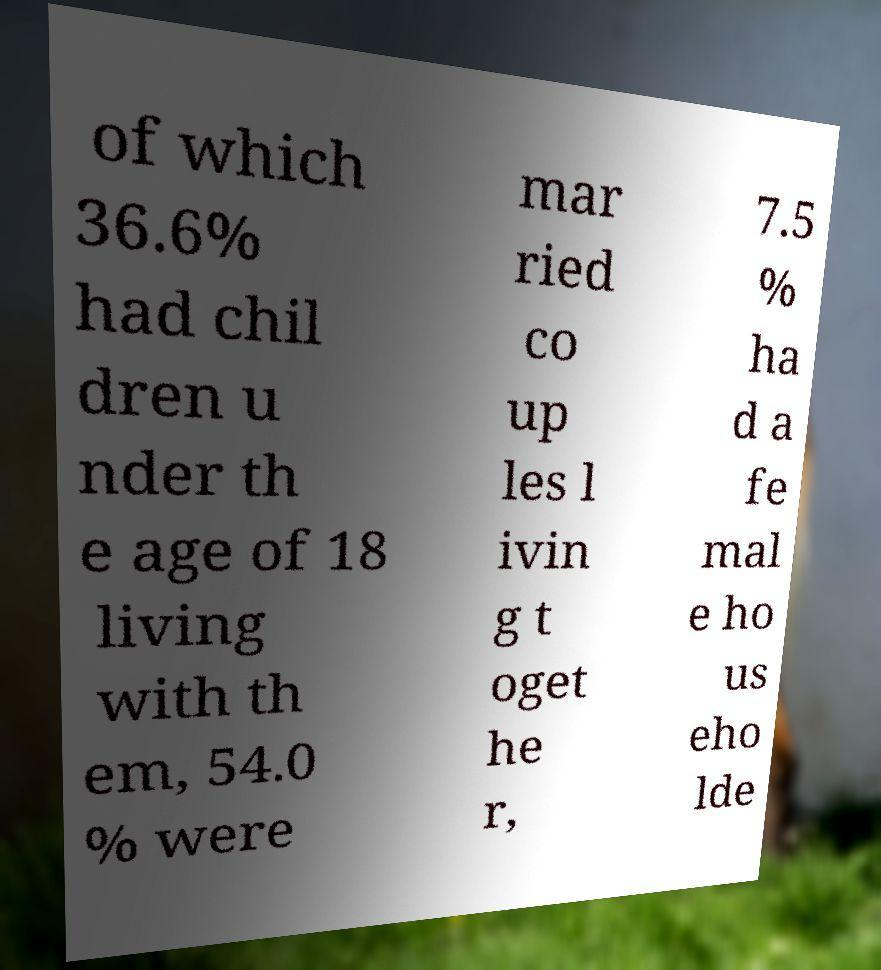I need the written content from this picture converted into text. Can you do that? of which 36.6% had chil dren u nder th e age of 18 living with th em, 54.0 % were mar ried co up les l ivin g t oget he r, 7.5 % ha d a fe mal e ho us eho lde 